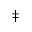<formula> <loc_0><loc_0><loc_500><loc_500>\ddagger</formula> 